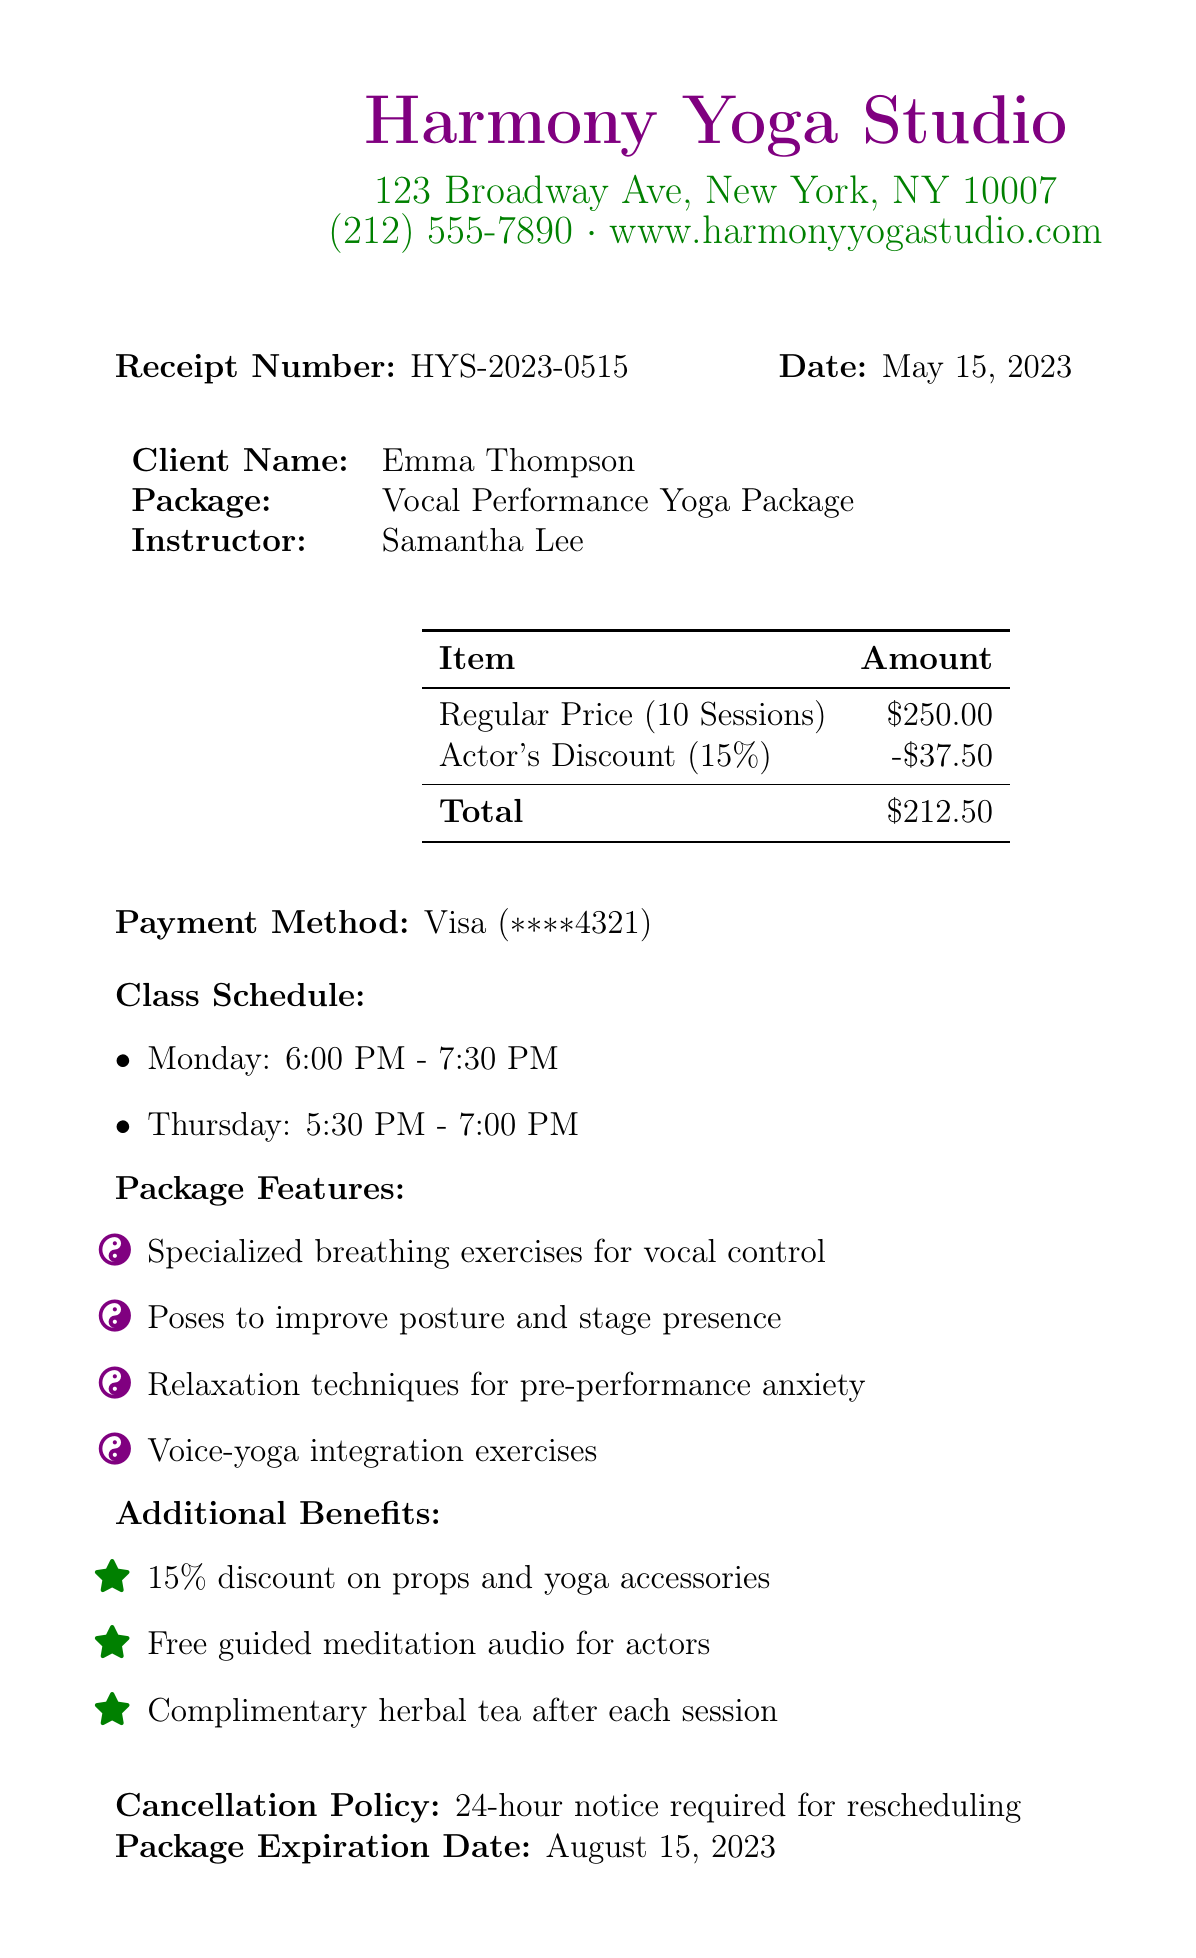What is the studio name? The studio name is mentioned at the top of the receipt.
Answer: Harmony Yoga Studio Who is the instructor? The instructor's name is listed in the document under the client information section.
Answer: Samantha Lee What is the total cost of the package after the discount? The total cost is calculated after applying the actor's discount to the regular price.
Answer: $212.50 How many sessions are included in the package? The number of sessions is explicitly stated in the document regarding the package details.
Answer: 10 On which day is the yoga class held at 6:00 PM? The schedule lists which day classes are held at specific times.
Answer: Monday What percentage is the actor discount? The document provides information about the discount percentage offered to actors.
Answer: 15% What is the cancellation policy? The policy is explicitly detailed towards the end of the document.
Answer: 24-hour notice required for rescheduling When does the package expire? The expiration date is mentioned towards the end of the receipt.
Answer: August 15, 2023 What additional benefit includes free meditation audio? The additional benefits section lists this specific offer for actors.
Answer: Free guided meditation audio for actors 